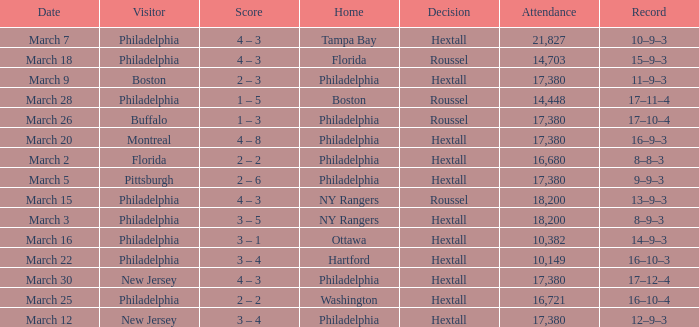Date of march 30 involves what home? Philadelphia. 